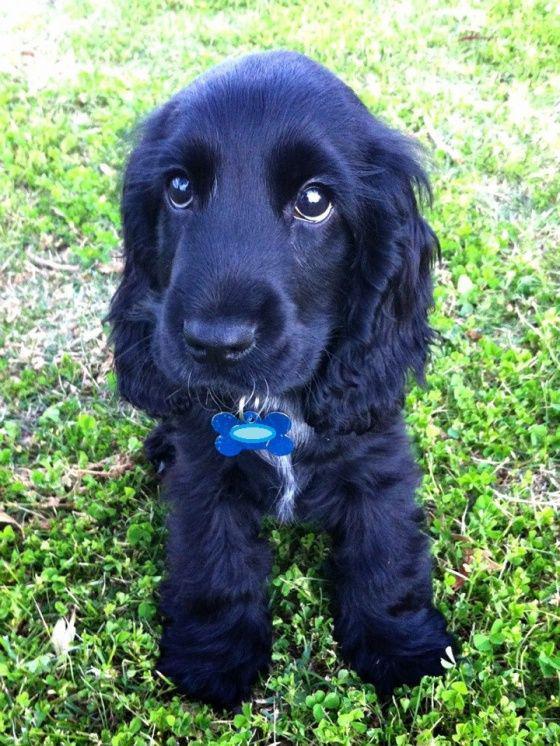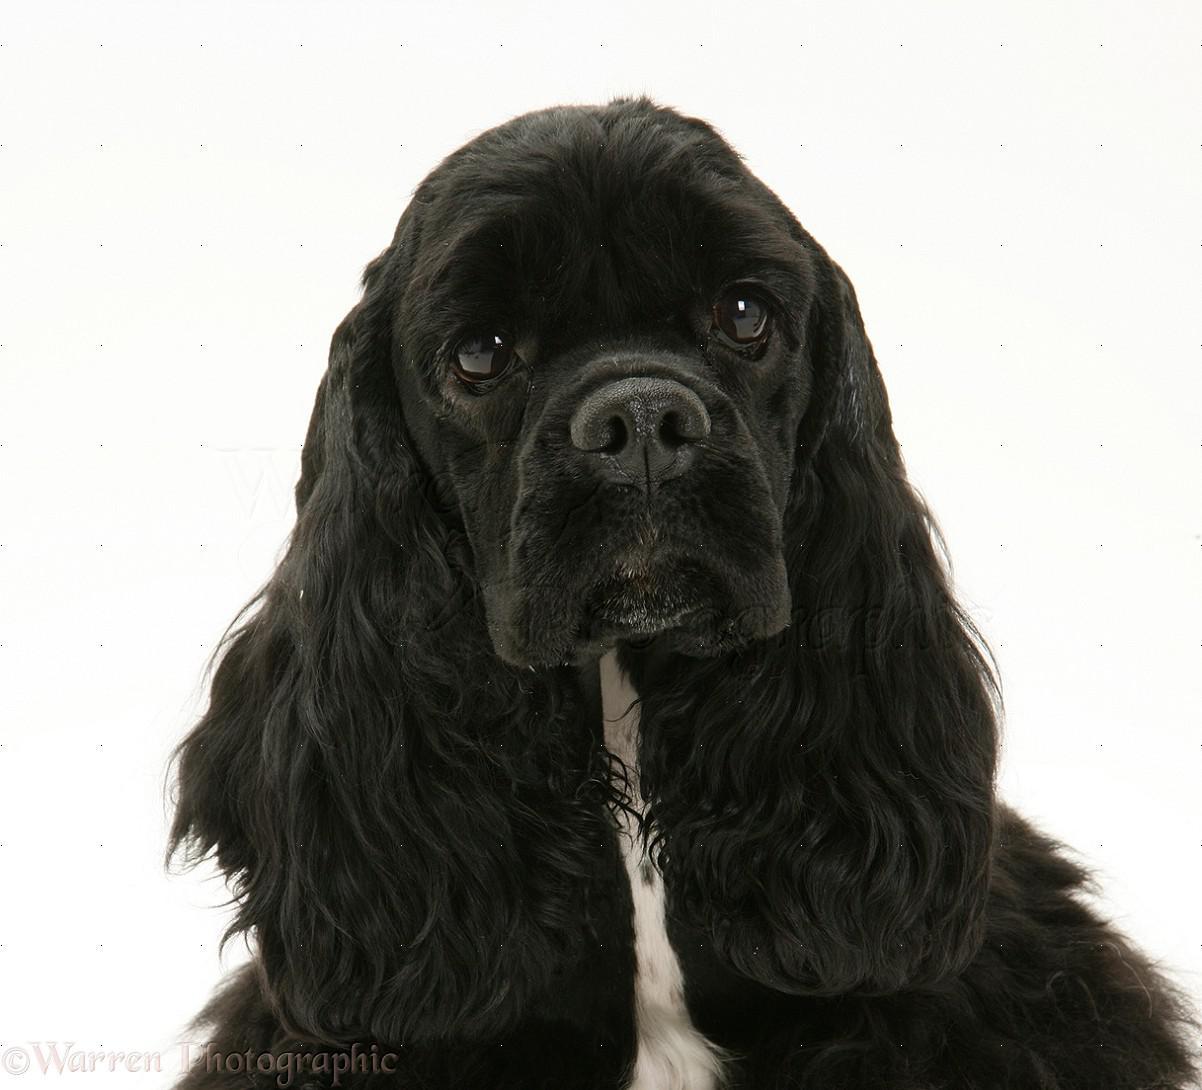The first image is the image on the left, the second image is the image on the right. Evaluate the accuracy of this statement regarding the images: "The left image contains two dark dogs.". Is it true? Answer yes or no. No. The first image is the image on the left, the second image is the image on the right. Examine the images to the left and right. Is the description "Two puppies sit together in the image on the left." accurate? Answer yes or no. No. 